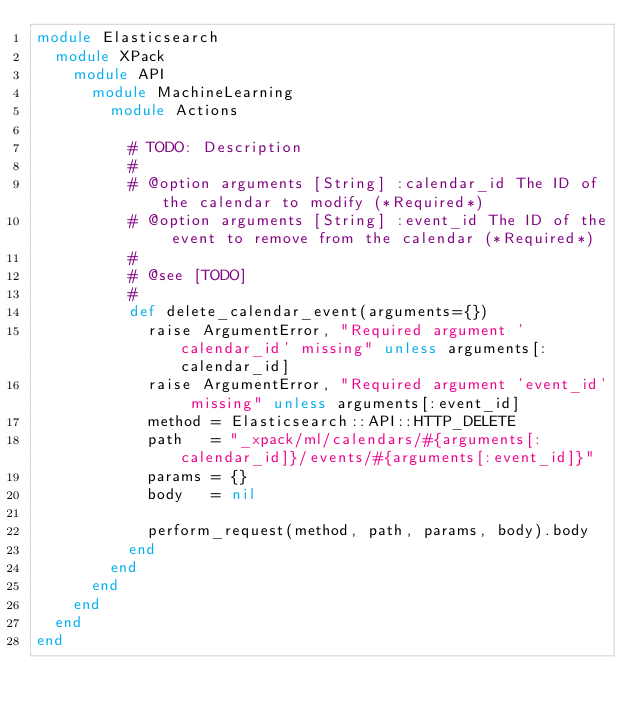<code> <loc_0><loc_0><loc_500><loc_500><_Ruby_>module Elasticsearch
  module XPack
    module API
      module MachineLearning
        module Actions

          # TODO: Description
          #
          # @option arguments [String] :calendar_id The ID of the calendar to modify (*Required*)
          # @option arguments [String] :event_id The ID of the event to remove from the calendar (*Required*)
          #
          # @see [TODO]
          #
          def delete_calendar_event(arguments={})
            raise ArgumentError, "Required argument 'calendar_id' missing" unless arguments[:calendar_id]
            raise ArgumentError, "Required argument 'event_id' missing" unless arguments[:event_id]
            method = Elasticsearch::API::HTTP_DELETE
            path   = "_xpack/ml/calendars/#{arguments[:calendar_id]}/events/#{arguments[:event_id]}"
            params = {}
            body   = nil

            perform_request(method, path, params, body).body
          end
        end
      end
    end
  end
end
</code> 